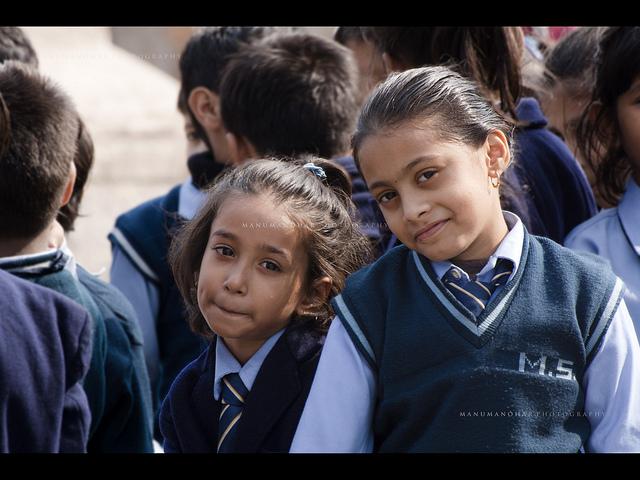Are both children smiling?
Write a very short answer. No. Does it appear cold in this picture?
Quick response, please. No. How many girls are in this photo?
Give a very brief answer. 2. How many children are there?
Give a very brief answer. 10. Is the girl's ear pierced?
Be succinct. Yes. 